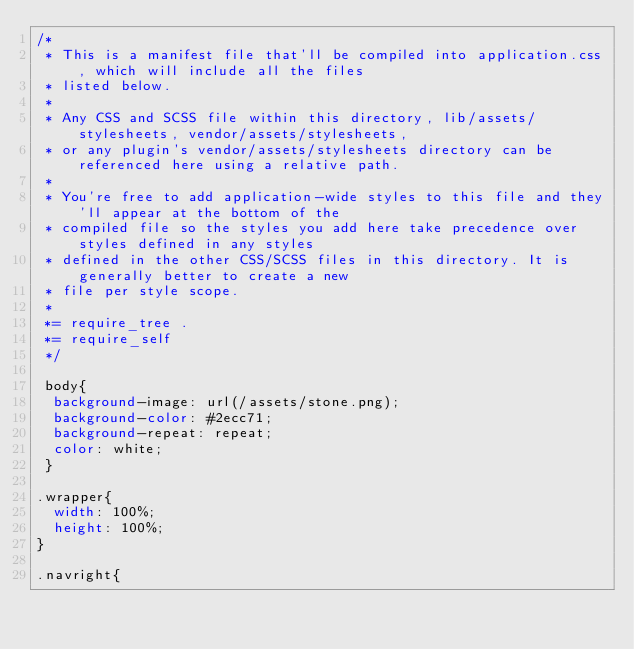<code> <loc_0><loc_0><loc_500><loc_500><_CSS_>/*
 * This is a manifest file that'll be compiled into application.css, which will include all the files
 * listed below.
 *
 * Any CSS and SCSS file within this directory, lib/assets/stylesheets, vendor/assets/stylesheets,
 * or any plugin's vendor/assets/stylesheets directory can be referenced here using a relative path.
 *
 * You're free to add application-wide styles to this file and they'll appear at the bottom of the
 * compiled file so the styles you add here take precedence over styles defined in any styles
 * defined in the other CSS/SCSS files in this directory. It is generally better to create a new
 * file per style scope.
 *
 *= require_tree .
 *= require_self
 */

 body{
  background-image: url(/assets/stone.png);
  background-color: #2ecc71;
  background-repeat: repeat;
  color: white;
 }

.wrapper{
  width: 100%;
  height: 100%;
}

.navright{</code> 